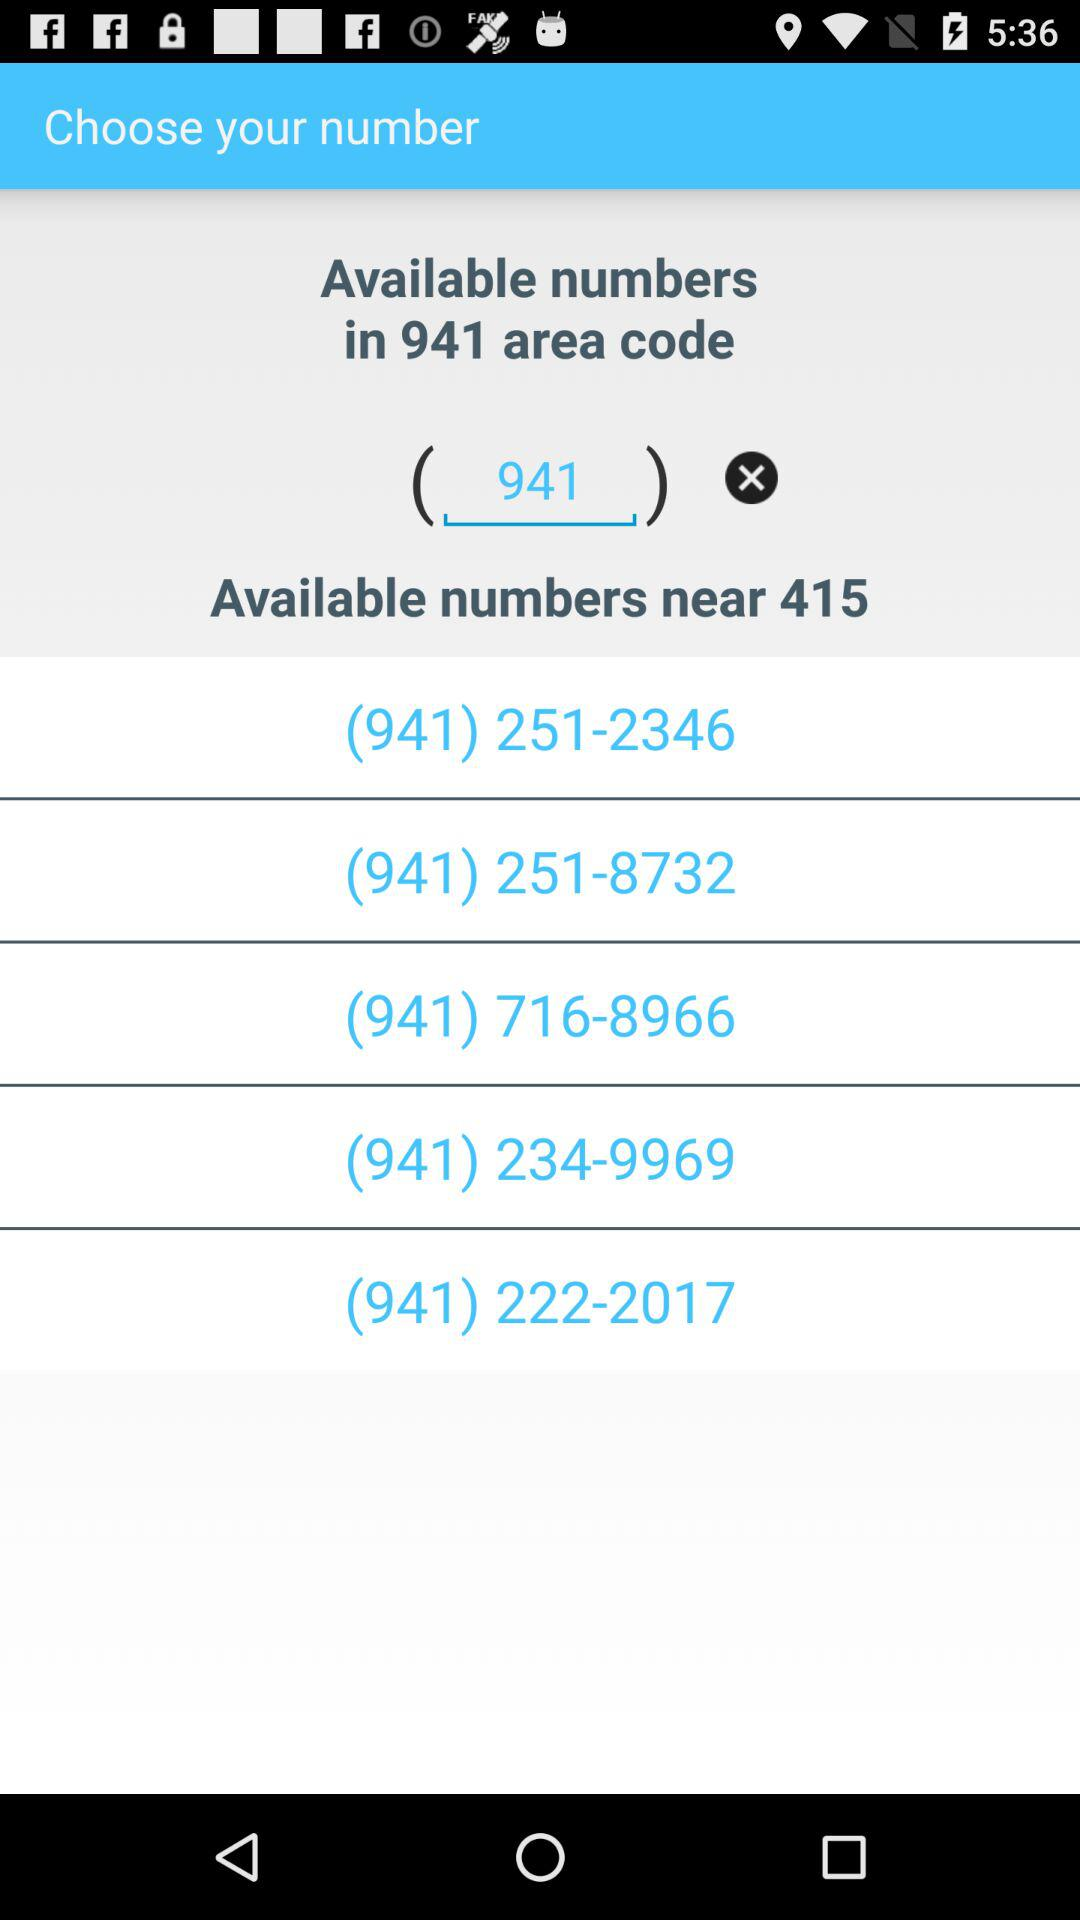How many available numbers are near? There are 415 available numbers near. 